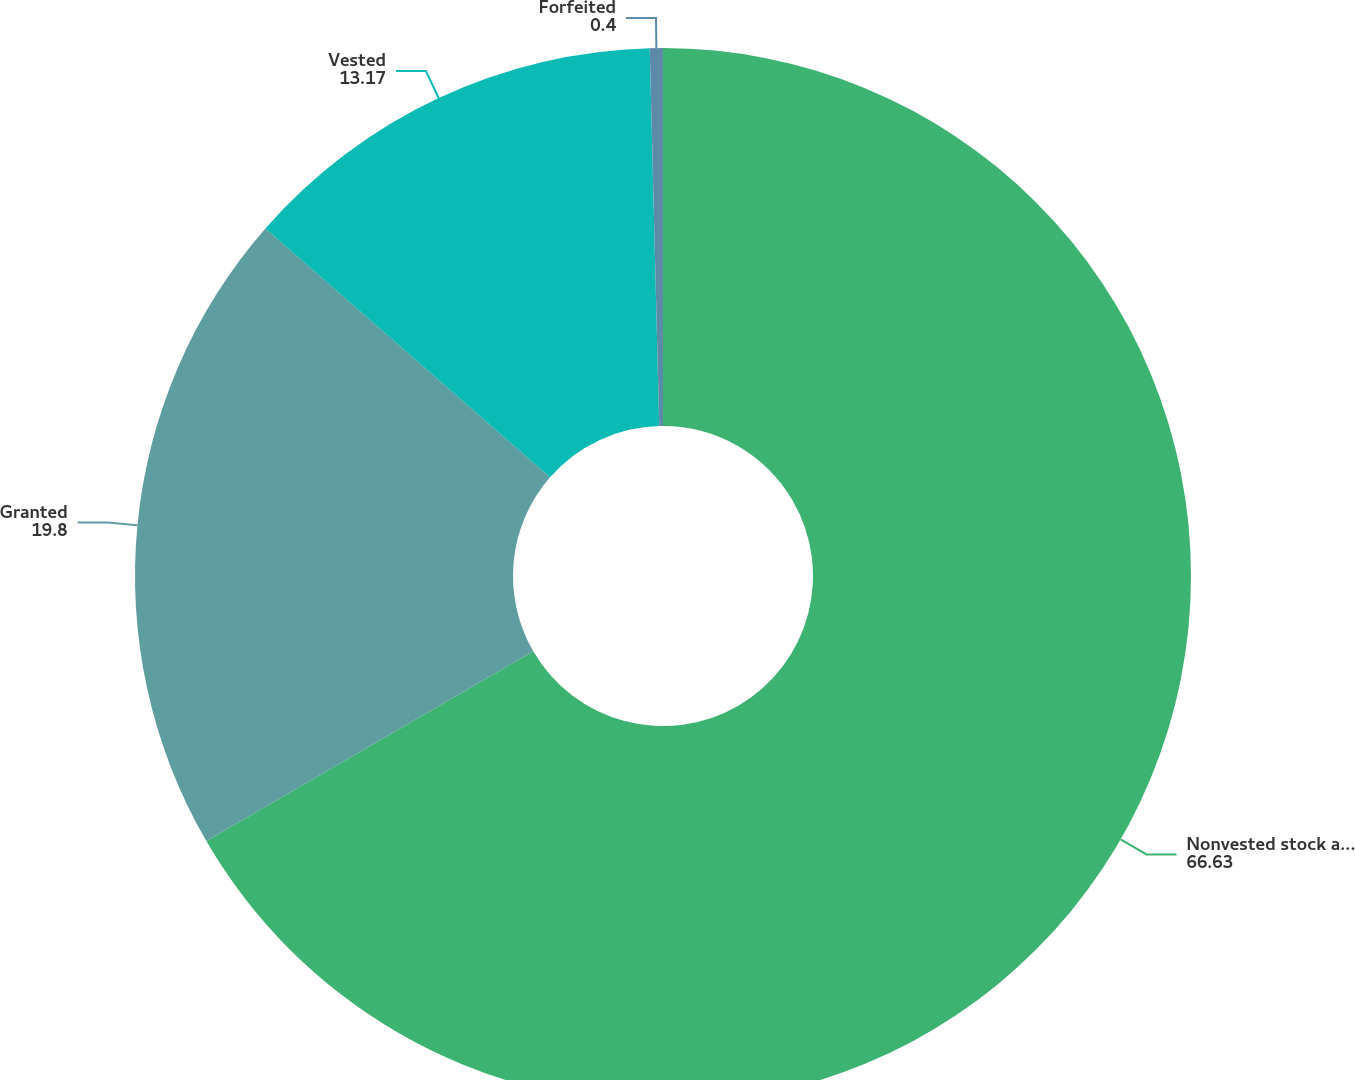Convert chart. <chart><loc_0><loc_0><loc_500><loc_500><pie_chart><fcel>Nonvested stock at December 31<fcel>Granted<fcel>Vested<fcel>Forfeited<nl><fcel>66.63%<fcel>19.8%<fcel>13.17%<fcel>0.4%<nl></chart> 